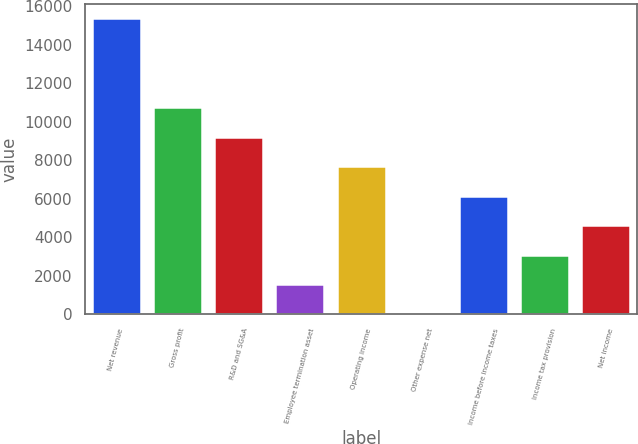Convert chart. <chart><loc_0><loc_0><loc_500><loc_500><bar_chart><fcel>Net revenue<fcel>Gross profit<fcel>R&D and SG&A<fcel>Employee termination asset<fcel>Operating income<fcel>Other expense net<fcel>Income before income taxes<fcel>Income tax provision<fcel>Net income<nl><fcel>15351<fcel>10758.9<fcel>9228.2<fcel>1574.7<fcel>7697.5<fcel>44<fcel>6166.8<fcel>3105.4<fcel>4636.1<nl></chart> 